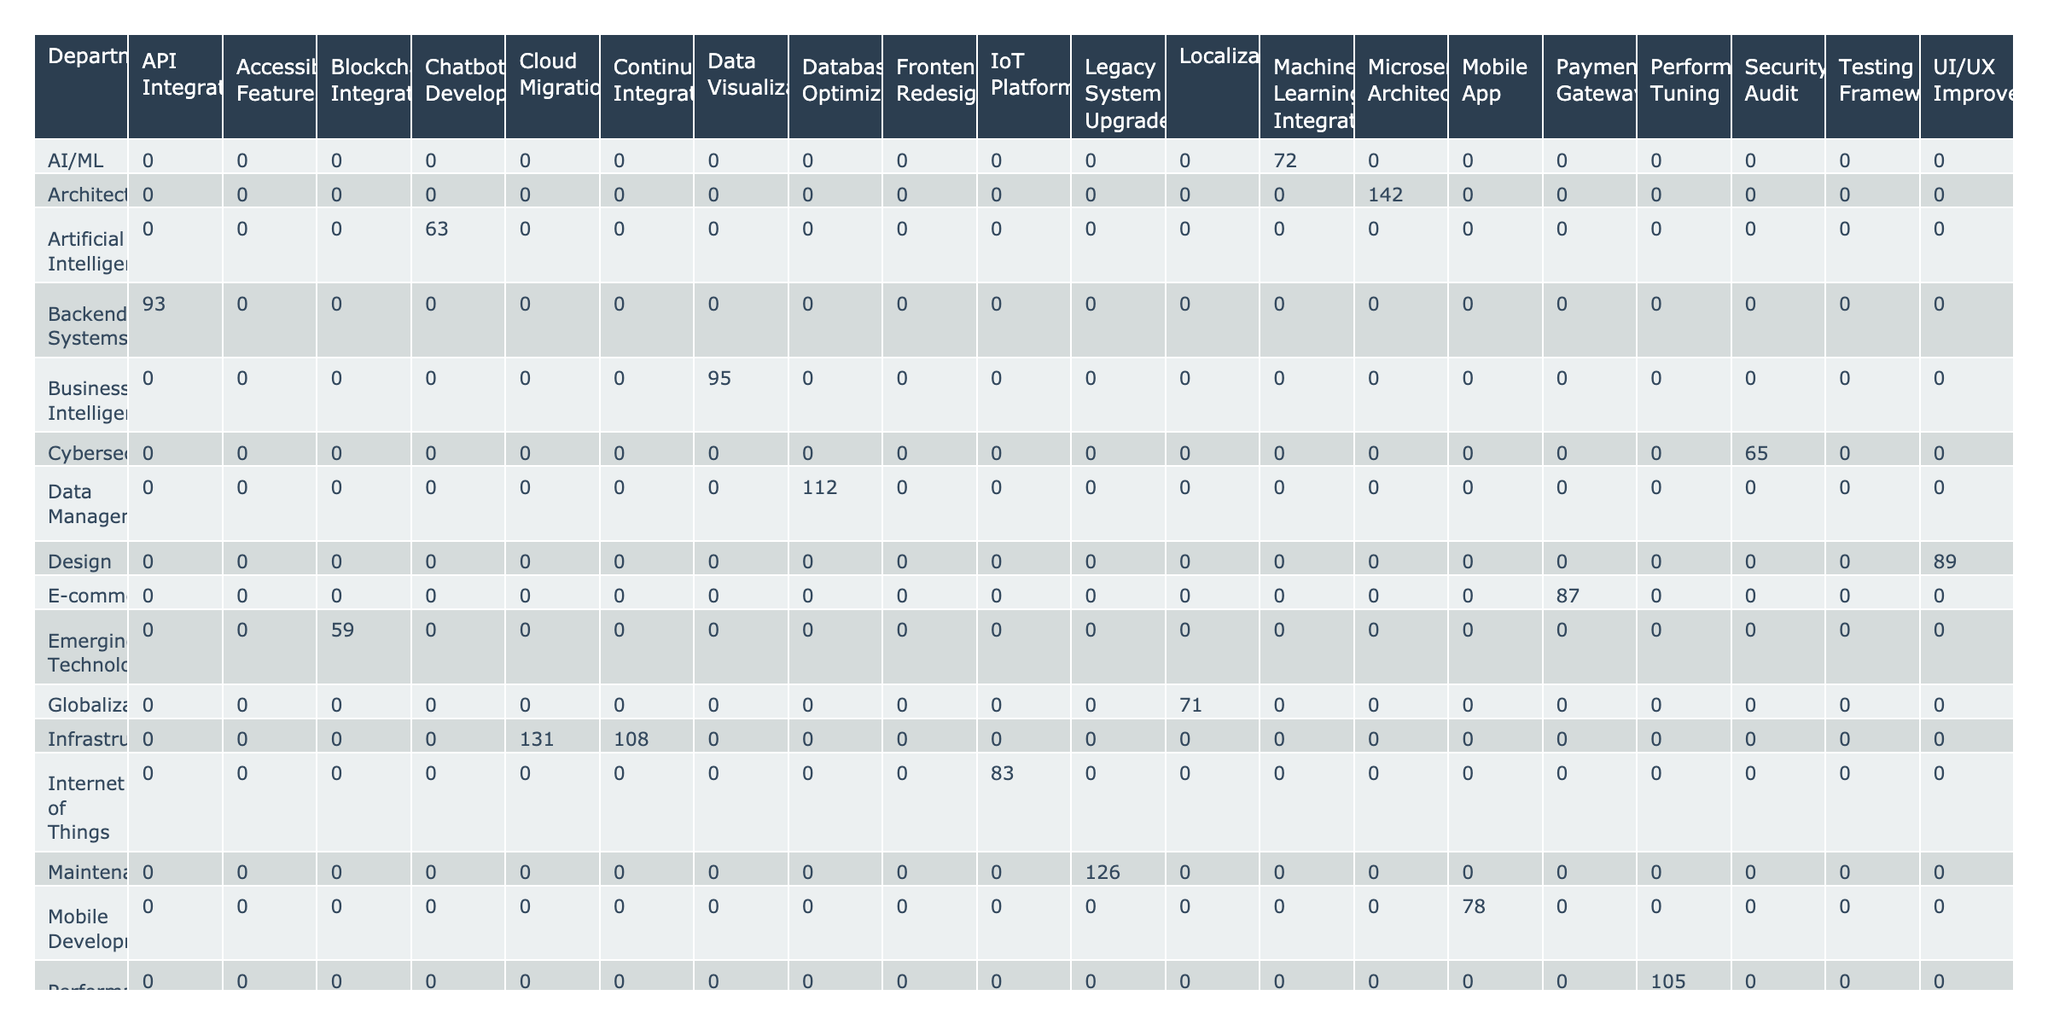What is the total number of contributions made by the Web Development department? The Web Development department has the contributions from Sarah Johnson (147) and no other contributions listed under this department in the table, so the total is 147.
Answer: 147 Which project had the highest contributions overall? To find the project with the highest contributions, we can look at the total contributions for each project. The highest contributions are from the "Frontend Redesign" with 147 contributions (Sarah Johnson) and "Microservices Architecture" with 142 contributions (Ryan Wilson). Since both contribute significantly, we can see that the highest individual contribution is from Sarah Johnson in the Frontend Redesign.
Answer: Frontend Redesign Is there a project in which the Mobile Development department contributed more than 80? The contributions from the Mobile Development department are only from Alex Thompson with 78 contributions for the Mobile App project, which is less than 80.
Answer: No How many contributions did the Infrastructure department make in total? The Infrastructure department includes contributions from David Lee (131) for Cloud Migration and Noah Anderson (108) for Continuous Integration. Adding these contributions gives 131 + 108 = 239.
Answer: 239 What is the average number of contributions across the Cybersecurity department? The Cybersecurity department has only one contribution from Olivia Patel, which is 65. To find the average, we divide the contributions (65) by the number of contributions (1), so the average is 65 / 1 = 65.
Answer: 65 Which department has the least overall contributions? To find the department with the least contributions, we need to sum the contributions for each department and compare them. The User Experience department (Ava Nguyen, 56) has the least contributions, totaling 56.
Answer: User Experience What is the difference in contributions between the highest and lowest contributions for the AI/ML department? The AI/ML department has Isabella Garcia contributing 63, while Sophia Wang contributes 72, meaning the highest contribution is 72. The difference is 72 - 63 = 9.
Answer: 9 Which role had the most contributions in the Business Intelligence department? The only contributor from the Business Intelligence department is Emma Collins, with 95 contributions as a Data Analyst.
Answer: Data Analyst How many projects did the Senior Developers contribute to in total? The Senior Developers contribute to two projects: Frontend Redesign (Sarah Johnson, 147) and Legacy System Upgrade (Sofia Kowalski, 126). Therefore, the total contributions are 147 + 126 = 273.
Answer: 273 